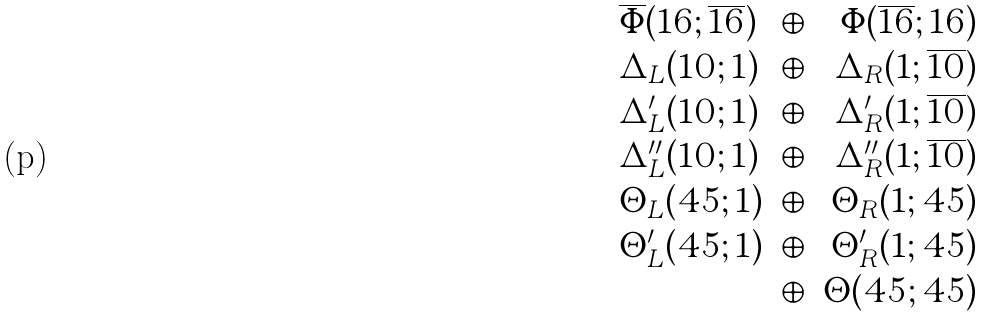Convert formula to latex. <formula><loc_0><loc_0><loc_500><loc_500>\begin{array} { l c r } \overline { \Phi } ( { 1 6 } ; \overline { 1 6 } ) & \oplus & \Phi ( \overline { 1 6 } ; { 1 6 } ) \\ \Delta _ { L } ( { 1 0 } ; { 1 } ) & \oplus & \Delta _ { R } ( { 1 } ; \overline { 1 0 } ) \\ \Delta ^ { \prime } _ { L } ( { 1 0 } ; { 1 } ) & \oplus & \Delta ^ { \prime } _ { R } ( { 1 } ; \overline { 1 0 } ) \\ \Delta ^ { \prime \prime } _ { L } ( { 1 0 } ; { 1 } ) & \oplus & \Delta ^ { \prime \prime } _ { R } ( { 1 } ; \overline { 1 0 } ) \\ \Theta _ { L } ( { 4 5 } ; { 1 } ) & \oplus & \Theta _ { R } ( { 1 } ; { 4 5 } ) \\ \Theta ^ { \prime } _ { L } ( { 4 5 } ; { 1 } ) & \oplus & \Theta ^ { \prime } _ { R } ( { 1 } ; { 4 5 } ) \\ & \oplus & \Theta ( { 4 5 } ; { 4 5 } ) \\ \end{array}</formula> 